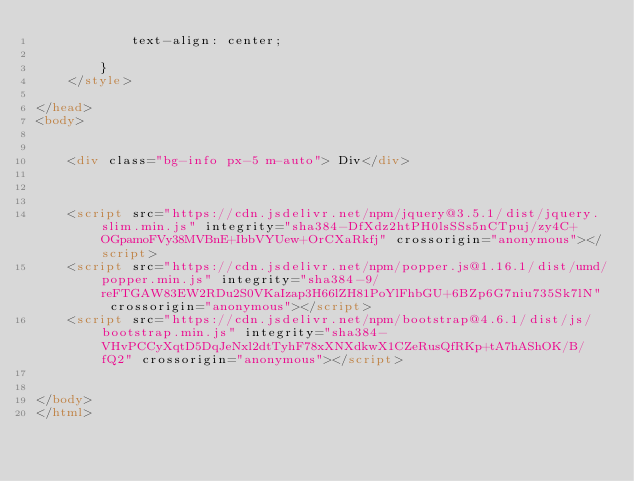<code> <loc_0><loc_0><loc_500><loc_500><_HTML_>            text-align: center;

        }
    </style>

</head>
<body>
     

    <div class="bg-info px-5 m-auto"> Div</div>



    <script src="https://cdn.jsdelivr.net/npm/jquery@3.5.1/dist/jquery.slim.min.js" integrity="sha384-DfXdz2htPH0lsSSs5nCTpuj/zy4C+OGpamoFVy38MVBnE+IbbVYUew+OrCXaRkfj" crossorigin="anonymous"></script>
    <script src="https://cdn.jsdelivr.net/npm/popper.js@1.16.1/dist/umd/popper.min.js" integrity="sha384-9/reFTGAW83EW2RDu2S0VKaIzap3H66lZH81PoYlFhbGU+6BZp6G7niu735Sk7lN" crossorigin="anonymous"></script>
    <script src="https://cdn.jsdelivr.net/npm/bootstrap@4.6.1/dist/js/bootstrap.min.js" integrity="sha384-VHvPCCyXqtD5DqJeNxl2dtTyhF78xXNXdkwX1CZeRusQfRKp+tA7hAShOK/B/fQ2" crossorigin="anonymous"></script>


</body>
</html></code> 